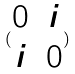Convert formula to latex. <formula><loc_0><loc_0><loc_500><loc_500>( \begin{matrix} 0 & i \\ i & 0 \end{matrix} )</formula> 